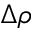<formula> <loc_0><loc_0><loc_500><loc_500>\Delta \rho</formula> 